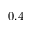<formula> <loc_0><loc_0><loc_500><loc_500>0 . 4</formula> 